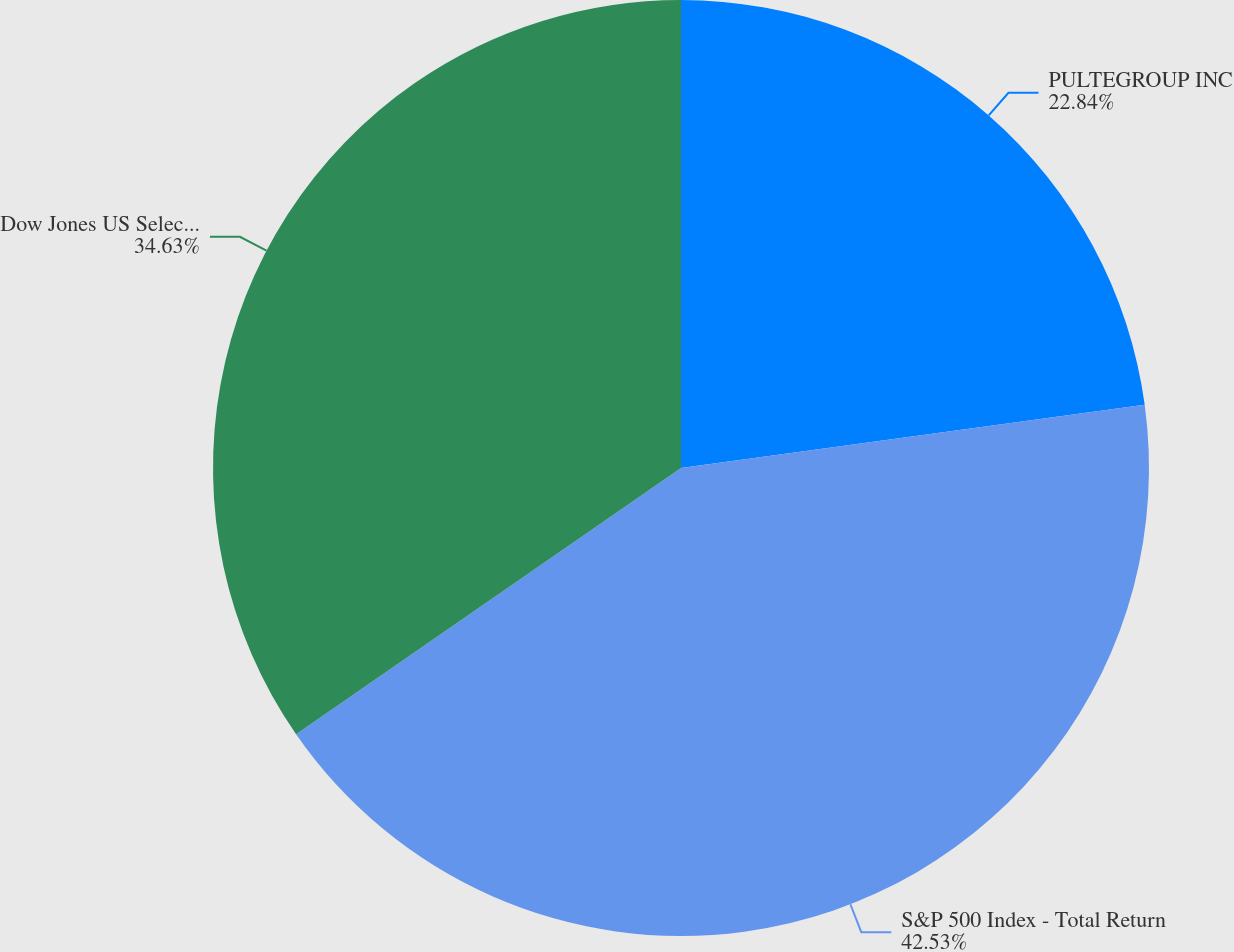Convert chart. <chart><loc_0><loc_0><loc_500><loc_500><pie_chart><fcel>PULTEGROUP INC<fcel>S&P 500 Index - Total Return<fcel>Dow Jones US Select Home<nl><fcel>22.84%<fcel>42.53%<fcel>34.63%<nl></chart> 